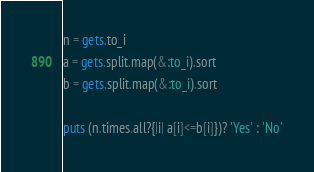<code> <loc_0><loc_0><loc_500><loc_500><_Ruby_>n = gets.to_i
a = gets.split.map(&:to_i).sort
b = gets.split.map(&:to_i).sort

puts (n.times.all?{|i| a[i]<=b[i]})? 'Yes' : 'No'
</code> 